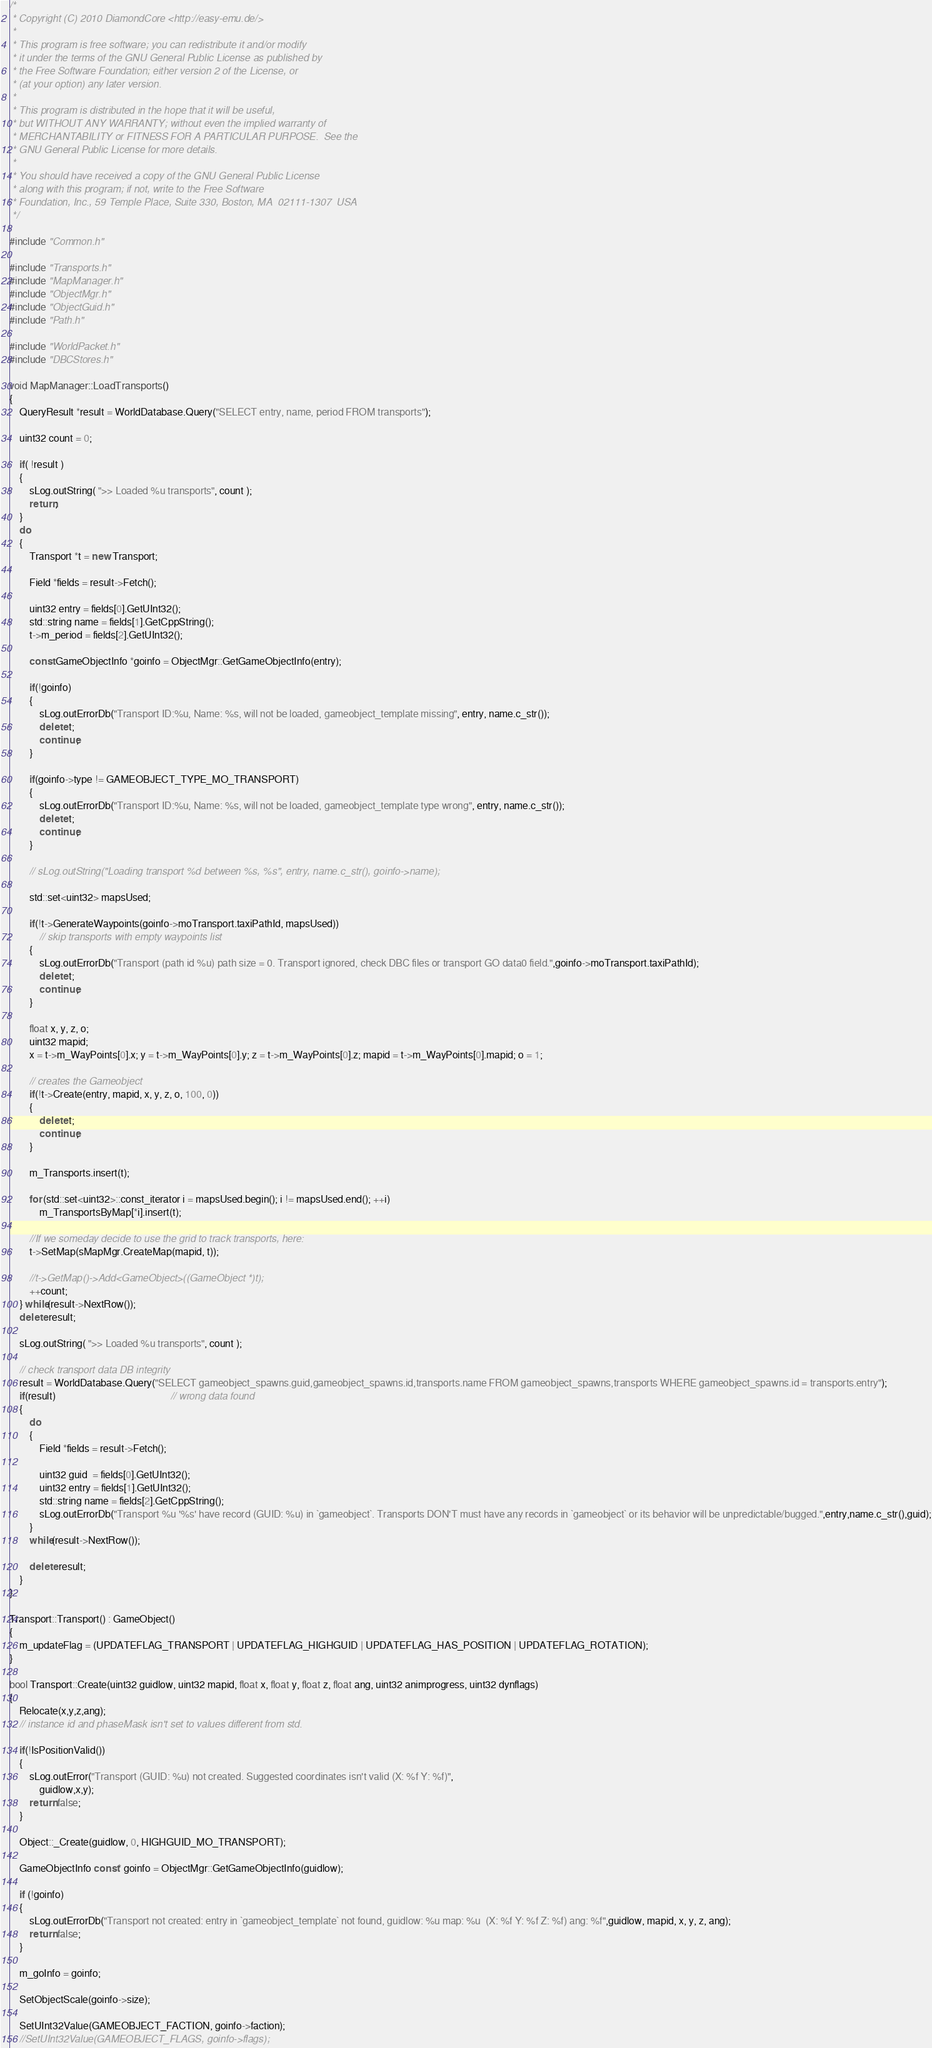Convert code to text. <code><loc_0><loc_0><loc_500><loc_500><_C++_>/*
 * Copyright (C) 2010 DiamondCore <http://easy-emu.de/>
 *
 * This program is free software; you can redistribute it and/or modify
 * it under the terms of the GNU General Public License as published by
 * the Free Software Foundation; either version 2 of the License, or
 * (at your option) any later version.
 *
 * This program is distributed in the hope that it will be useful,
 * but WITHOUT ANY WARRANTY; without even the implied warranty of
 * MERCHANTABILITY or FITNESS FOR A PARTICULAR PURPOSE.  See the
 * GNU General Public License for more details.
 *
 * You should have received a copy of the GNU General Public License
 * along with this program; if not, write to the Free Software
 * Foundation, Inc., 59 Temple Place, Suite 330, Boston, MA  02111-1307  USA
 */

#include "Common.h"

#include "Transports.h"
#include "MapManager.h"
#include "ObjectMgr.h"
#include "ObjectGuid.h"
#include "Path.h"

#include "WorldPacket.h"
#include "DBCStores.h"

void MapManager::LoadTransports()
{
    QueryResult *result = WorldDatabase.Query("SELECT entry, name, period FROM transports");

    uint32 count = 0;

    if( !result )
    {
        sLog.outString( ">> Loaded %u transports", count );
        return;
    }
    do
    {
        Transport *t = new Transport;

        Field *fields = result->Fetch();

        uint32 entry = fields[0].GetUInt32();
        std::string name = fields[1].GetCppString();
        t->m_period = fields[2].GetUInt32();

        const GameObjectInfo *goinfo = ObjectMgr::GetGameObjectInfo(entry);

        if(!goinfo)
        {
            sLog.outErrorDb("Transport ID:%u, Name: %s, will not be loaded, gameobject_template missing", entry, name.c_str());
            delete t;
            continue;
        }

        if(goinfo->type != GAMEOBJECT_TYPE_MO_TRANSPORT)
        {
            sLog.outErrorDb("Transport ID:%u, Name: %s, will not be loaded, gameobject_template type wrong", entry, name.c_str());
            delete t;
            continue;
        }

        // sLog.outString("Loading transport %d between %s, %s", entry, name.c_str(), goinfo->name);

        std::set<uint32> mapsUsed;

        if(!t->GenerateWaypoints(goinfo->moTransport.taxiPathId, mapsUsed))
            // skip transports with empty waypoints list
        {
            sLog.outErrorDb("Transport (path id %u) path size = 0. Transport ignored, check DBC files or transport GO data0 field.",goinfo->moTransport.taxiPathId);
            delete t;
            continue;
        }

        float x, y, z, o;
        uint32 mapid;
        x = t->m_WayPoints[0].x; y = t->m_WayPoints[0].y; z = t->m_WayPoints[0].z; mapid = t->m_WayPoints[0].mapid; o = 1;

        // creates the Gameobject
        if(!t->Create(entry, mapid, x, y, z, o, 100, 0))
        {
            delete t;
            continue;
        }

        m_Transports.insert(t);

        for (std::set<uint32>::const_iterator i = mapsUsed.begin(); i != mapsUsed.end(); ++i)
            m_TransportsByMap[*i].insert(t);

        //If we someday decide to use the grid to track transports, here:
        t->SetMap(sMapMgr.CreateMap(mapid, t));

        //t->GetMap()->Add<GameObject>((GameObject *)t);
        ++count;
    } while(result->NextRow());
    delete result;

    sLog.outString( ">> Loaded %u transports", count );

    // check transport data DB integrity
    result = WorldDatabase.Query("SELECT gameobject_spawns.guid,gameobject_spawns.id,transports.name FROM gameobject_spawns,transports WHERE gameobject_spawns.id = transports.entry");
    if(result)                                              // wrong data found
    {
        do
        {
            Field *fields = result->Fetch();

            uint32 guid  = fields[0].GetUInt32();
            uint32 entry = fields[1].GetUInt32();
            std::string name = fields[2].GetCppString();
            sLog.outErrorDb("Transport %u '%s' have record (GUID: %u) in `gameobject`. Transports DON'T must have any records in `gameobject` or its behavior will be unpredictable/bugged.",entry,name.c_str(),guid);
        }
        while(result->NextRow());

        delete result;
    }
}

Transport::Transport() : GameObject()
{
    m_updateFlag = (UPDATEFLAG_TRANSPORT | UPDATEFLAG_HIGHGUID | UPDATEFLAG_HAS_POSITION | UPDATEFLAG_ROTATION);
}

bool Transport::Create(uint32 guidlow, uint32 mapid, float x, float y, float z, float ang, uint32 animprogress, uint32 dynflags)
{
    Relocate(x,y,z,ang);
    // instance id and phaseMask isn't set to values different from std.

    if(!IsPositionValid())
    {
        sLog.outError("Transport (GUID: %u) not created. Suggested coordinates isn't valid (X: %f Y: %f)",
            guidlow,x,y);
        return false;
    }

    Object::_Create(guidlow, 0, HIGHGUID_MO_TRANSPORT);

    GameObjectInfo const* goinfo = ObjectMgr::GetGameObjectInfo(guidlow);

    if (!goinfo)
    {
        sLog.outErrorDb("Transport not created: entry in `gameobject_template` not found, guidlow: %u map: %u  (X: %f Y: %f Z: %f) ang: %f",guidlow, mapid, x, y, z, ang);
        return false;
    }

    m_goInfo = goinfo;

    SetObjectScale(goinfo->size);

    SetUInt32Value(GAMEOBJECT_FACTION, goinfo->faction);
    //SetUInt32Value(GAMEOBJECT_FLAGS, goinfo->flags);</code> 